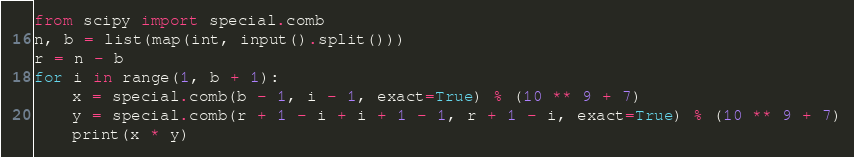<code> <loc_0><loc_0><loc_500><loc_500><_Python_>from scipy import special.comb
n, b = list(map(int, input().split()))
r = n - b
for i in range(1, b + 1):
    x = special.comb(b - 1, i - 1, exact=True) % (10 ** 9 + 7)
    y = special.comb(r + 1 - i + i + 1 - 1, r + 1 - i, exact=True) % (10 ** 9 + 7)
    print(x * y)
</code> 